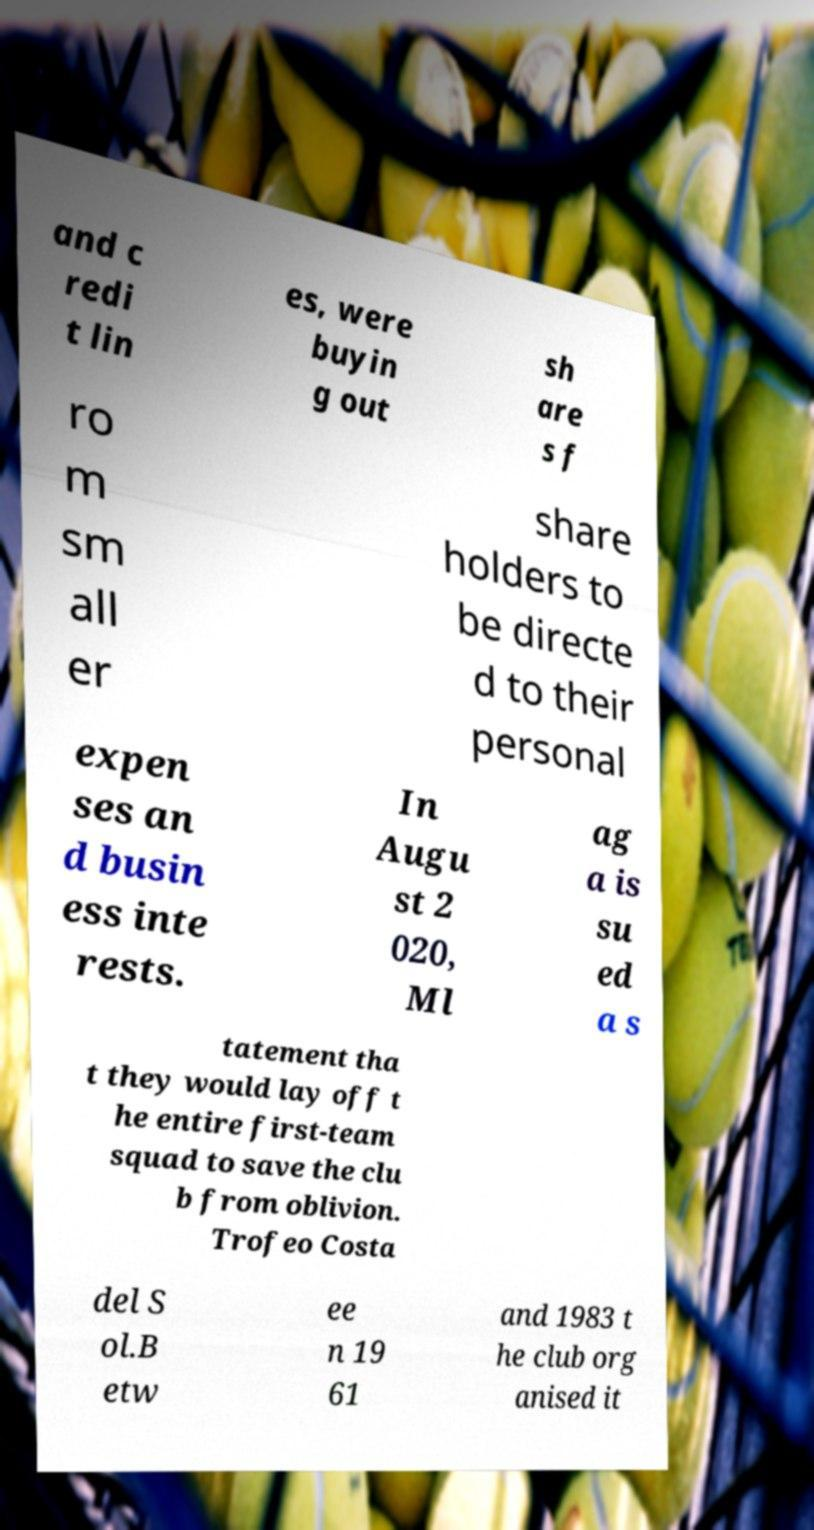There's text embedded in this image that I need extracted. Can you transcribe it verbatim? and c redi t lin es, were buyin g out sh are s f ro m sm all er share holders to be directe d to their personal expen ses an d busin ess inte rests. In Augu st 2 020, Ml ag a is su ed a s tatement tha t they would lay off t he entire first-team squad to save the clu b from oblivion. Trofeo Costa del S ol.B etw ee n 19 61 and 1983 t he club org anised it 